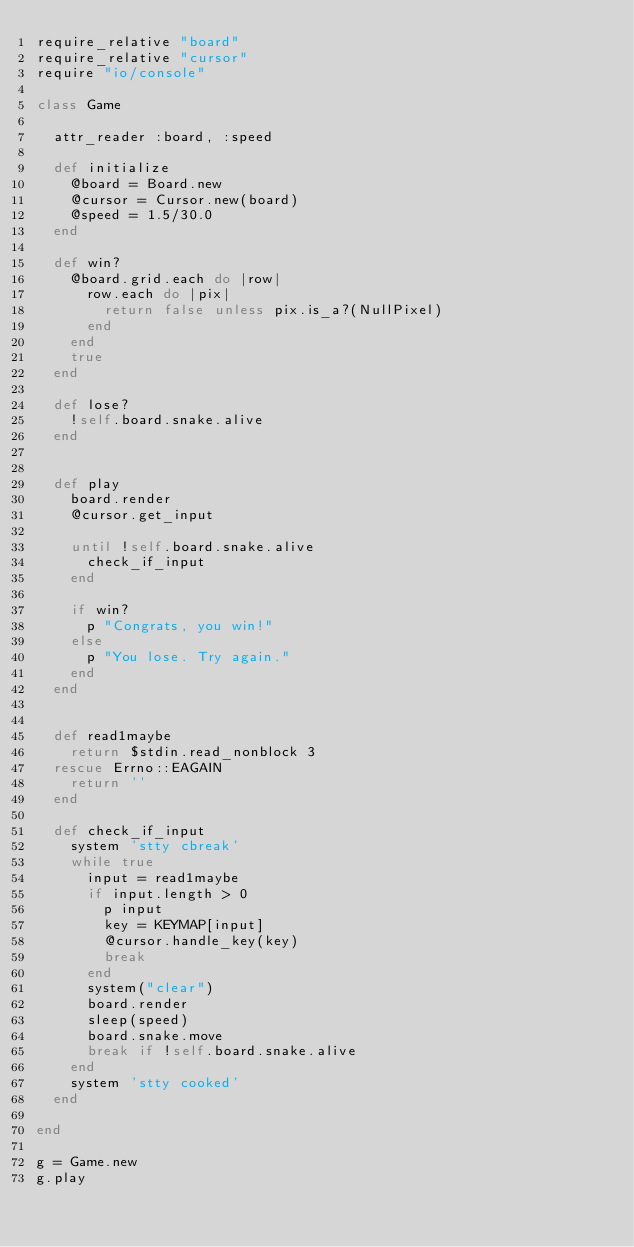<code> <loc_0><loc_0><loc_500><loc_500><_Ruby_>require_relative "board"
require_relative "cursor"
require "io/console"

class Game

  attr_reader :board, :speed

  def initialize
    @board = Board.new
    @cursor = Cursor.new(board)
    @speed = 1.5/30.0
  end

  def win?
    @board.grid.each do |row|
      row.each do |pix|
        return false unless pix.is_a?(NullPixel)
      end
    end
    true
  end

  def lose?
    !self.board.snake.alive
  end


  def play
    board.render
    @cursor.get_input

    until !self.board.snake.alive
      check_if_input
    end

    if win?
      p "Congrats, you win!"
    else
      p "You lose. Try again."
    end
  end


  def read1maybe
    return $stdin.read_nonblock 3
  rescue Errno::EAGAIN
    return ''
  end
  
  def check_if_input
    system 'stty cbreak'
    while true
      input = read1maybe
      if input.length > 0 
        p input
        key = KEYMAP[input]
        @cursor.handle_key(key)
        break 
      end
      system("clear")
      board.render
      sleep(speed)
      board.snake.move
      break if !self.board.snake.alive
    end
    system 'stty cooked'
  end

end

g = Game.new
g.play
</code> 